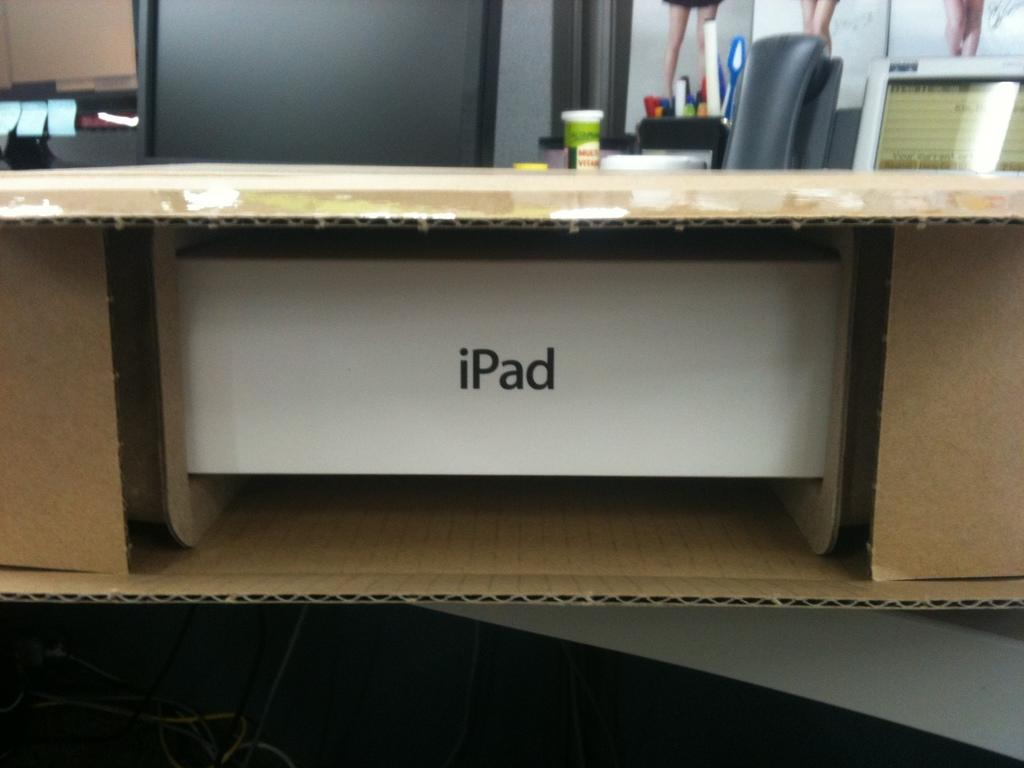What object is visible in the image that could be used for packaging or storage? There is a cardboard box in the image. What is inside the cardboard box? The cardboard box contains an "iPad". What electronic device is visible behind the cardboard box? There is a monitor behind the cardboard box. What stationery item is present on the table? A pen stand is present on the table. How does the son contribute to the party in the image? There is no mention of a son or a party in the image. The image only features a cardboard box, an "iPad", a monitor, and a pen stand. 